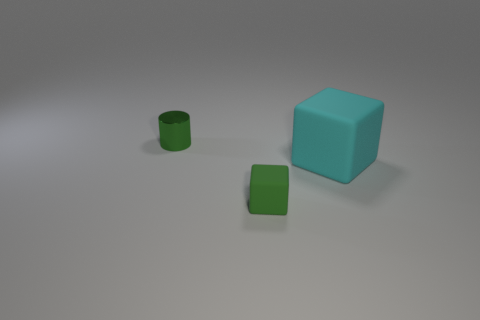Are there any green metal cylinders on the right side of the tiny green thing in front of the large cyan cube?
Make the answer very short. No. What is the shape of the tiny green matte thing?
Provide a short and direct response. Cube. What is the size of the other thing that is the same color as the tiny matte thing?
Provide a short and direct response. Small. There is a rubber object that is left of the matte object that is behind the tiny green rubber object; how big is it?
Provide a succinct answer. Small. There is a green object that is on the right side of the green shiny cylinder; what size is it?
Make the answer very short. Small. Is the number of large blocks that are in front of the large cyan object less than the number of small cubes left of the tiny matte thing?
Provide a succinct answer. No. What is the color of the big thing?
Offer a terse response. Cyan. Is there a tiny metal object that has the same color as the tiny matte object?
Keep it short and to the point. Yes. What shape is the green object that is in front of the object that is on the right side of the tiny green object that is right of the metal object?
Your response must be concise. Cube. What is the material of the tiny object that is behind the cyan cube?
Make the answer very short. Metal. 